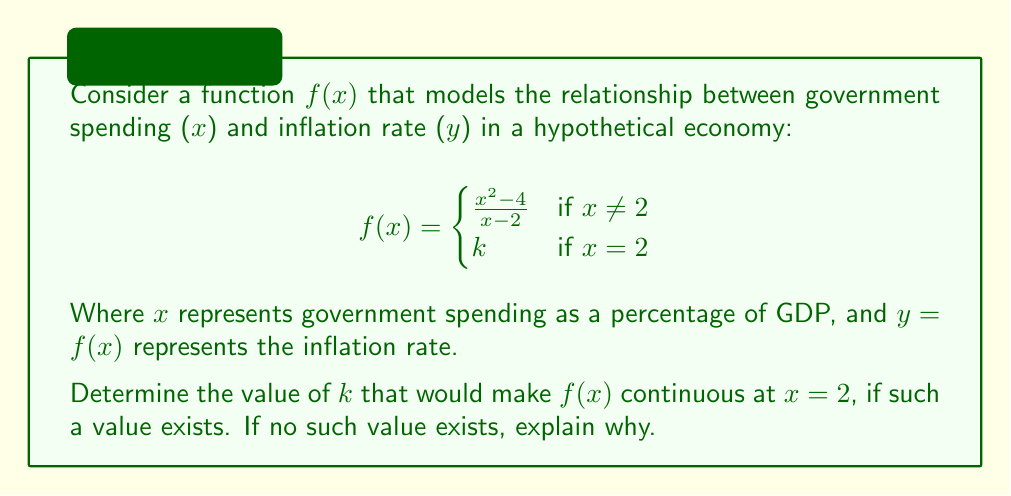Could you help me with this problem? To determine if $f(x)$ is continuous at $x = 2$, we need to check if the limit of $f(x)$ as $x$ approaches 2 from both sides exists and is equal to $f(2)$.

1) First, let's calculate the limit as $x$ approaches 2:

   $\lim_{x \to 2} f(x) = \lim_{x \to 2} \frac{x^2 - 4}{x - 2}$

2) This is an indeterminate form (0/0), so we can use L'Hôpital's rule or factor the numerator:

   $\lim_{x \to 2} \frac{x^2 - 4}{x - 2} = \lim_{x \to 2} \frac{(x+2)(x-2)}{x - 2} = \lim_{x \to 2} (x+2) = 4$

3) Now, for $f(x)$ to be continuous at $x = 2$, we need:

   $\lim_{x \to 2} f(x) = f(2)$

4) We found that $\lim_{x \to 2} f(x) = 4$, so for continuity, we need:

   $4 = f(2) = k$

Therefore, $f(x)$ will be continuous at $x = 2$ if and only if $k = 4$.

From a political economy perspective, this result suggests that the relationship between government spending and inflation remains smooth and predictable even at the critical point where spending reaches 2% of GDP, contrary to some beliefs that there might be a sudden jump or discontinuity in inflation at certain spending thresholds.
Answer: The function $f(x)$ is continuous at $x = 2$ if and only if $k = 4$. 